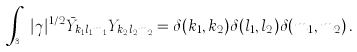<formula> <loc_0><loc_0><loc_500><loc_500>\int _ { \mathbb { S } ^ { 3 } } | \gamma | ^ { 1 / 2 } \bar { Y } _ { k _ { 1 } l _ { 1 } m _ { 1 } } Y _ { k _ { 2 } l _ { 2 } m _ { 2 } } = \delta ( k _ { 1 } , k _ { 2 } ) \delta ( l _ { 1 } , l _ { 2 } ) \delta ( m _ { 1 } , m _ { 2 } ) \, .</formula> 